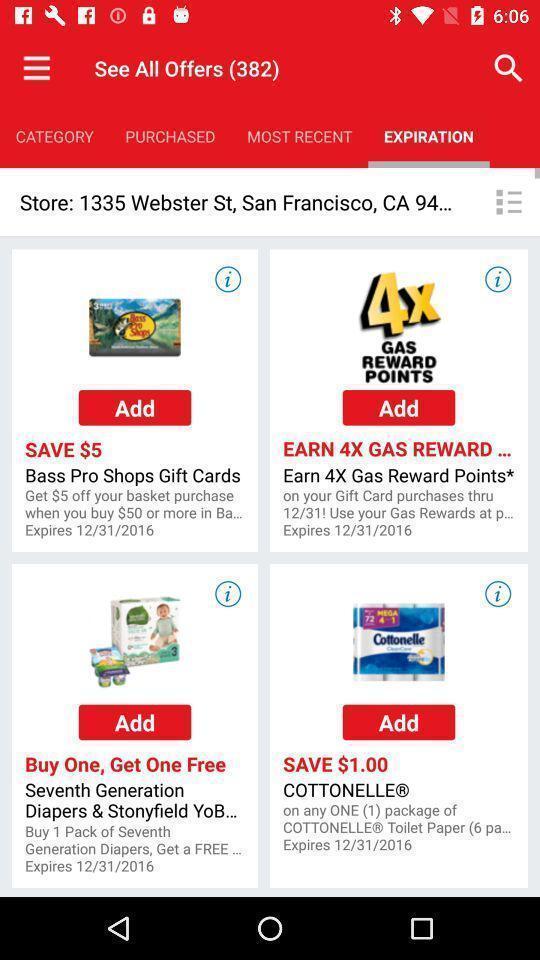Describe this image in words. Page showing offers on different items. 